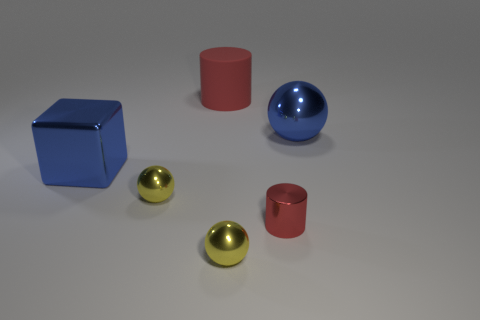Are there fewer big blocks that are left of the large metal block than small metal spheres on the right side of the rubber thing?
Make the answer very short. Yes. Are the blue block and the large ball made of the same material?
Provide a succinct answer. Yes. What material is the sphere that is to the right of the big red cylinder and in front of the blue ball?
Your response must be concise. Metal. What number of big blue cubes are there?
Your answer should be very brief. 1. Are there any other things that are the same shape as the red metallic object?
Offer a very short reply. Yes. Is the material of the red cylinder that is behind the metal cylinder the same as the ball that is behind the large cube?
Offer a very short reply. No. What material is the big red thing?
Keep it short and to the point. Rubber. How many large red things are the same material as the blue sphere?
Keep it short and to the point. 0. How many metal objects are small yellow cubes or cylinders?
Make the answer very short. 1. There is a large blue thing that is behind the large cube; is it the same shape as the red metal object that is to the right of the large metal block?
Provide a short and direct response. No. 